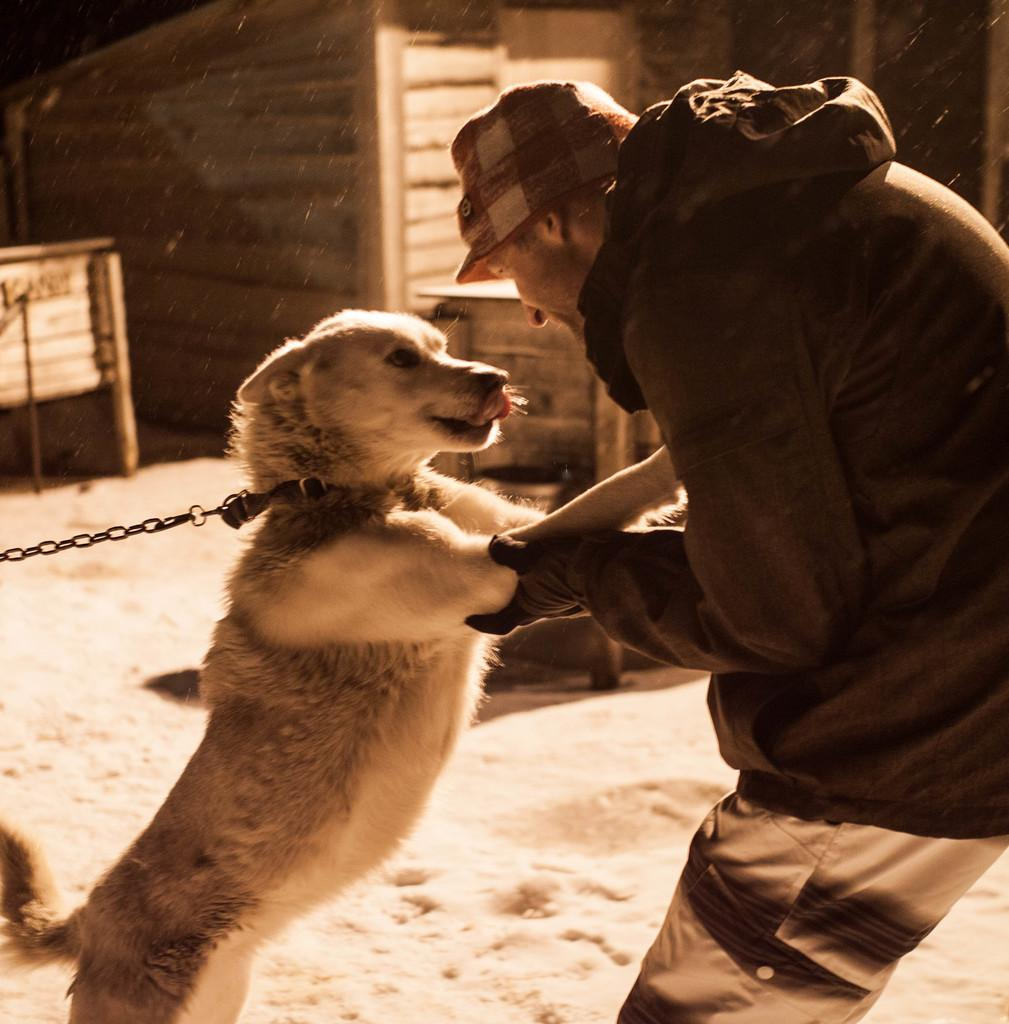What is the person in the image doing? The person is standing in the image and holding a dog. What is the person wearing in the image? The person is wearing a cap in the image. What can be seen in the background of the image? There is a wooden door in the background of the image. What type of nut is the person cracking in the image? There is no nut present in the image; the person is holding a dog. How does the person care for the bomb in the image? There is no bomb present in the image; the person is holding a dog. 